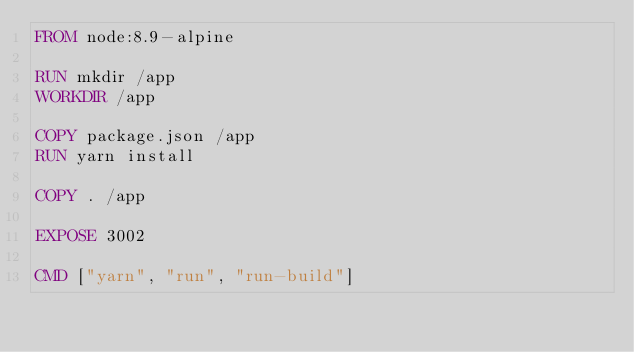Convert code to text. <code><loc_0><loc_0><loc_500><loc_500><_Dockerfile_>FROM node:8.9-alpine

RUN mkdir /app
WORKDIR /app

COPY package.json /app
RUN yarn install

COPY . /app

EXPOSE 3002

CMD ["yarn", "run", "run-build"]</code> 